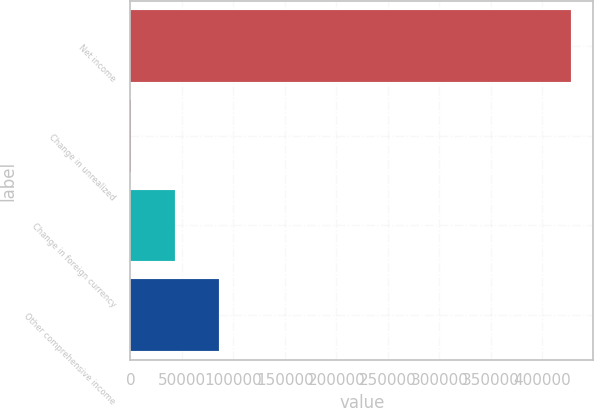Convert chart to OTSL. <chart><loc_0><loc_0><loc_500><loc_500><bar_chart><fcel>Net income<fcel>Change in unrealized<fcel>Change in foreign currency<fcel>Other comprehensive income<nl><fcel>428259<fcel>143<fcel>42954.6<fcel>85766.2<nl></chart> 